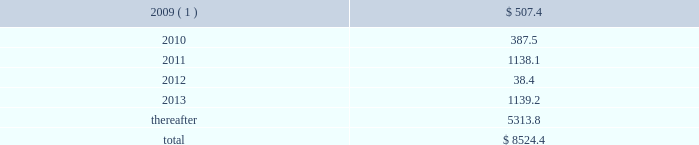The number of shares issued will be determined as the par value of the debentures divided by the average trading stock price over the preceding five-day period .
At december 31 , 2008 , the unamortized adjustment to fair value for these debentures was $ 28.7 million , which is being amortized through april 15 , 2011 , the first date that the holders can require us to redeem the debentures .
Tax-exempt financings as of december 31 , 2008 and 2007 , we had $ 1.3 billion and $ .7 billion of fixed and variable rate tax-exempt financings outstanding , respectively , with maturities ranging from 2010 to 2037 .
During 2008 , we issued $ 207.4 million of tax-exempt bonds .
In addition , we acquired $ 527.0 million of tax-exempt bonds and other tax-exempt financings as part of our acquisition of allied in december 2008 .
At december 31 , 2008 , the total of the unamortized adjustments to fair value for these financings was $ 52.9 million , which is being amortized to interest expense over the remaining terms of the debt .
Approximately two-thirds of our tax-exempt financings are remarketed weekly or daily , by a remarketing agent to effectively maintain a variable yield .
These variable rate tax-exempt financings are credit enhanced with letters of credit having terms in excess of one year issued by banks with credit ratings of aa or better .
The holders of the bonds can put them back to the remarketing agent at the end of each interest period .
To date , the remarketing agents have been able to remarket our variable rate unsecured tax-exempt bonds .
As of december 31 , 2008 , we had $ 281.9 million of restricted cash , of which $ 133.5 million was proceeds from the issuance of tax-exempt bonds and other tax-exempt financings and will be used to fund capital expenditures under the terms of the agreements .
Restricted cash also includes amounts held in trust as a financial guarantee of our performance .
Other debt other debt primarily includes capital lease liabilities of $ 139.5 million and $ 35.4 million as of december 31 , 2008 and 2007 , respectively , with maturities ranging from 2009 to 2042 .
Future maturities of debt aggregate maturities of notes payable , capital leases and other long-term debt as of december 31 , 2008 , excluding non-cash discounts , premiums , adjustments to fair market value of related to hedging transactions and adjustments to fair market value recorded in purchase accounting totaling $ 821.9 million , are as follows ( in millions ) : years ending december 31 , 2009 ( 1 ) .
$ 507.4 .
( 1 ) includes the receivables secured loan , which is a 364-day liquidity facility with a maturity date of may 29 , 2009 and has a balance of $ 400.0 million at december 31 , 2008 .
Although we intend to renew the liquidity facility prior to its maturity date , the outstanding balance is classified as a current liability because it has a contractual maturity of less than one year .
Republic services , inc .
And subsidiaries notes to consolidated financial statements %%transmsg*** transmitting job : p14076 pcn : 119000000 ***%%pcmsg|117 |00024|yes|no|02/28/2009 17:21|0|0|page is valid , no graphics -- color : d| .
What is the ratio in the future maturities of debt aggregate maturities from 2013 to 2012? 
Rationale: for every $ 1 of future maturities in 2012 there was $ 29.7 in 2013
Computations: (1139.2 / 38.4)
Answer: 29.66667. 